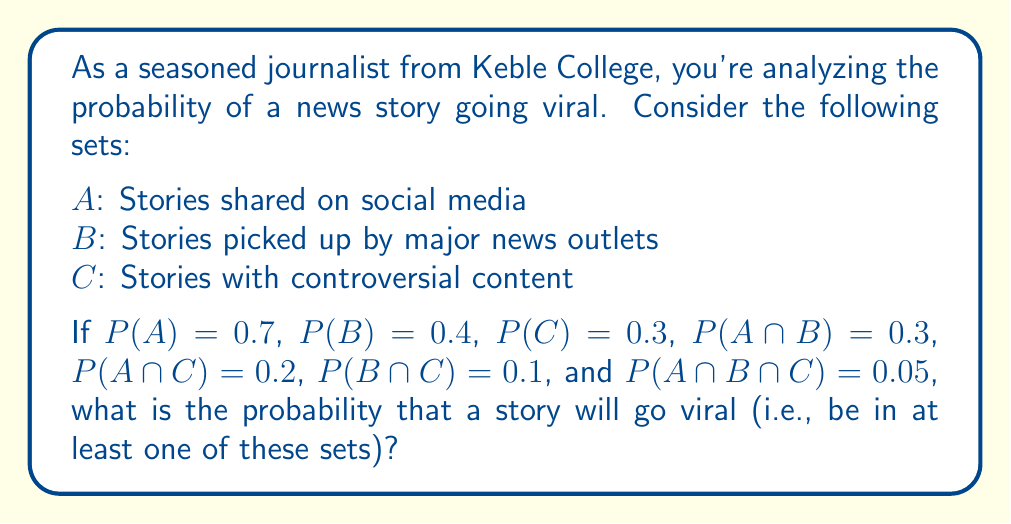What is the answer to this math problem? To solve this problem, we need to use the Inclusion-Exclusion Principle for three sets. The formula for the probability of the union of three sets is:

$$P(A \cup B \cup C) = P(A) + P(B) + P(C) - P(A \cap B) - P(A \cap C) - P(B \cap C) + P(A \cap B \cap C)$$

Let's substitute the given probabilities into this formula:

$$\begin{align*}
P(A \cup B \cup C) &= 0.7 + 0.4 + 0.3 - 0.3 - 0.2 - 0.1 + 0.05 \\
&= 1.4 - 0.6 + 0.05 \\
&= 0.85
\end{align*}$$

This calculation gives us the probability that a story will be in at least one of the sets A, B, or C, which represents the probability of the story going viral according to our defined criteria.
Answer: The probability that a news story will go viral is 0.85 or 85%. 